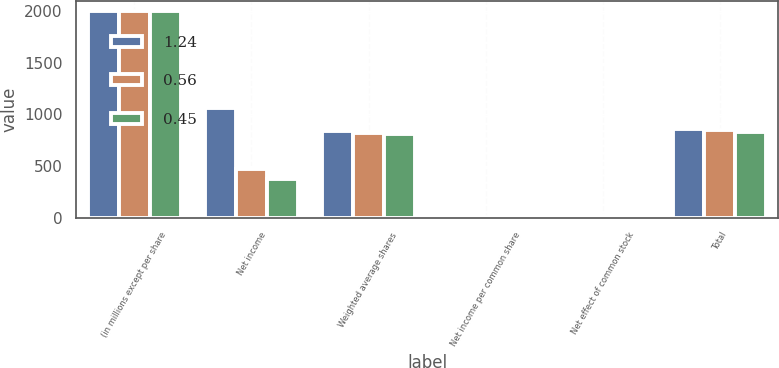Convert chart. <chart><loc_0><loc_0><loc_500><loc_500><stacked_bar_chart><ecel><fcel>(in millions except per share<fcel>Net income<fcel>Weighted average shares<fcel>Net income per common share<fcel>Net effect of common stock<fcel>Total<nl><fcel>1.24<fcel>2004<fcel>1062<fcel>838.2<fcel>1.27<fcel>19.5<fcel>857.7<nl><fcel>0.56<fcel>2003<fcel>472<fcel>821<fcel>0.57<fcel>24.4<fcel>845.4<nl><fcel>0.45<fcel>2002<fcel>373<fcel>814.2<fcel>0.46<fcel>15.8<fcel>830<nl></chart> 